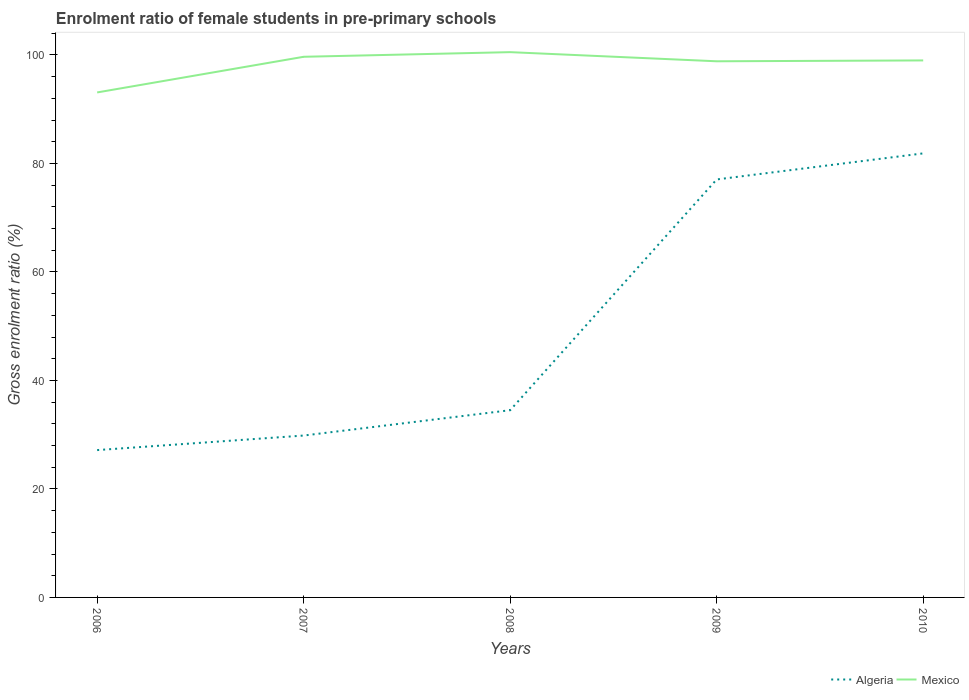How many different coloured lines are there?
Make the answer very short. 2. Does the line corresponding to Mexico intersect with the line corresponding to Algeria?
Provide a short and direct response. No. Across all years, what is the maximum enrolment ratio of female students in pre-primary schools in Algeria?
Your answer should be very brief. 27.16. In which year was the enrolment ratio of female students in pre-primary schools in Algeria maximum?
Ensure brevity in your answer.  2006. What is the total enrolment ratio of female students in pre-primary schools in Algeria in the graph?
Keep it short and to the point. -7.36. What is the difference between the highest and the second highest enrolment ratio of female students in pre-primary schools in Mexico?
Keep it short and to the point. 7.43. Is the enrolment ratio of female students in pre-primary schools in Algeria strictly greater than the enrolment ratio of female students in pre-primary schools in Mexico over the years?
Your answer should be compact. Yes. How many lines are there?
Provide a succinct answer. 2. How many years are there in the graph?
Offer a very short reply. 5. What is the difference between two consecutive major ticks on the Y-axis?
Offer a very short reply. 20. Does the graph contain any zero values?
Make the answer very short. No. Where does the legend appear in the graph?
Provide a succinct answer. Bottom right. How many legend labels are there?
Ensure brevity in your answer.  2. How are the legend labels stacked?
Your answer should be very brief. Horizontal. What is the title of the graph?
Give a very brief answer. Enrolment ratio of female students in pre-primary schools. What is the label or title of the X-axis?
Ensure brevity in your answer.  Years. What is the label or title of the Y-axis?
Your answer should be very brief. Gross enrolment ratio (%). What is the Gross enrolment ratio (%) of Algeria in 2006?
Offer a very short reply. 27.16. What is the Gross enrolment ratio (%) in Mexico in 2006?
Ensure brevity in your answer.  93.1. What is the Gross enrolment ratio (%) of Algeria in 2007?
Make the answer very short. 29.84. What is the Gross enrolment ratio (%) in Mexico in 2007?
Ensure brevity in your answer.  99.67. What is the Gross enrolment ratio (%) of Algeria in 2008?
Make the answer very short. 34.52. What is the Gross enrolment ratio (%) of Mexico in 2008?
Your answer should be very brief. 100.52. What is the Gross enrolment ratio (%) in Algeria in 2009?
Ensure brevity in your answer.  77.06. What is the Gross enrolment ratio (%) of Mexico in 2009?
Provide a short and direct response. 98.84. What is the Gross enrolment ratio (%) in Algeria in 2010?
Keep it short and to the point. 81.86. What is the Gross enrolment ratio (%) of Mexico in 2010?
Your answer should be very brief. 99. Across all years, what is the maximum Gross enrolment ratio (%) of Algeria?
Give a very brief answer. 81.86. Across all years, what is the maximum Gross enrolment ratio (%) in Mexico?
Keep it short and to the point. 100.52. Across all years, what is the minimum Gross enrolment ratio (%) in Algeria?
Your response must be concise. 27.16. Across all years, what is the minimum Gross enrolment ratio (%) of Mexico?
Give a very brief answer. 93.1. What is the total Gross enrolment ratio (%) of Algeria in the graph?
Ensure brevity in your answer.  250.44. What is the total Gross enrolment ratio (%) of Mexico in the graph?
Offer a terse response. 491.13. What is the difference between the Gross enrolment ratio (%) in Algeria in 2006 and that in 2007?
Offer a very short reply. -2.68. What is the difference between the Gross enrolment ratio (%) of Mexico in 2006 and that in 2007?
Give a very brief answer. -6.57. What is the difference between the Gross enrolment ratio (%) in Algeria in 2006 and that in 2008?
Give a very brief answer. -7.36. What is the difference between the Gross enrolment ratio (%) in Mexico in 2006 and that in 2008?
Provide a succinct answer. -7.43. What is the difference between the Gross enrolment ratio (%) of Algeria in 2006 and that in 2009?
Give a very brief answer. -49.9. What is the difference between the Gross enrolment ratio (%) of Mexico in 2006 and that in 2009?
Offer a very short reply. -5.74. What is the difference between the Gross enrolment ratio (%) of Algeria in 2006 and that in 2010?
Your answer should be very brief. -54.7. What is the difference between the Gross enrolment ratio (%) of Mexico in 2006 and that in 2010?
Offer a terse response. -5.9. What is the difference between the Gross enrolment ratio (%) of Algeria in 2007 and that in 2008?
Ensure brevity in your answer.  -4.67. What is the difference between the Gross enrolment ratio (%) in Mexico in 2007 and that in 2008?
Give a very brief answer. -0.86. What is the difference between the Gross enrolment ratio (%) of Algeria in 2007 and that in 2009?
Keep it short and to the point. -47.21. What is the difference between the Gross enrolment ratio (%) of Mexico in 2007 and that in 2009?
Provide a short and direct response. 0.83. What is the difference between the Gross enrolment ratio (%) in Algeria in 2007 and that in 2010?
Offer a terse response. -52.02. What is the difference between the Gross enrolment ratio (%) in Mexico in 2007 and that in 2010?
Make the answer very short. 0.67. What is the difference between the Gross enrolment ratio (%) in Algeria in 2008 and that in 2009?
Your response must be concise. -42.54. What is the difference between the Gross enrolment ratio (%) of Mexico in 2008 and that in 2009?
Provide a short and direct response. 1.68. What is the difference between the Gross enrolment ratio (%) in Algeria in 2008 and that in 2010?
Offer a very short reply. -47.34. What is the difference between the Gross enrolment ratio (%) of Mexico in 2008 and that in 2010?
Your response must be concise. 1.52. What is the difference between the Gross enrolment ratio (%) in Algeria in 2009 and that in 2010?
Keep it short and to the point. -4.8. What is the difference between the Gross enrolment ratio (%) of Mexico in 2009 and that in 2010?
Give a very brief answer. -0.16. What is the difference between the Gross enrolment ratio (%) of Algeria in 2006 and the Gross enrolment ratio (%) of Mexico in 2007?
Your response must be concise. -72.51. What is the difference between the Gross enrolment ratio (%) in Algeria in 2006 and the Gross enrolment ratio (%) in Mexico in 2008?
Offer a terse response. -73.36. What is the difference between the Gross enrolment ratio (%) of Algeria in 2006 and the Gross enrolment ratio (%) of Mexico in 2009?
Keep it short and to the point. -71.68. What is the difference between the Gross enrolment ratio (%) of Algeria in 2006 and the Gross enrolment ratio (%) of Mexico in 2010?
Ensure brevity in your answer.  -71.84. What is the difference between the Gross enrolment ratio (%) of Algeria in 2007 and the Gross enrolment ratio (%) of Mexico in 2008?
Your response must be concise. -70.68. What is the difference between the Gross enrolment ratio (%) of Algeria in 2007 and the Gross enrolment ratio (%) of Mexico in 2009?
Give a very brief answer. -69. What is the difference between the Gross enrolment ratio (%) of Algeria in 2007 and the Gross enrolment ratio (%) of Mexico in 2010?
Offer a terse response. -69.15. What is the difference between the Gross enrolment ratio (%) in Algeria in 2008 and the Gross enrolment ratio (%) in Mexico in 2009?
Give a very brief answer. -64.32. What is the difference between the Gross enrolment ratio (%) of Algeria in 2008 and the Gross enrolment ratio (%) of Mexico in 2010?
Offer a very short reply. -64.48. What is the difference between the Gross enrolment ratio (%) in Algeria in 2009 and the Gross enrolment ratio (%) in Mexico in 2010?
Offer a very short reply. -21.94. What is the average Gross enrolment ratio (%) in Algeria per year?
Give a very brief answer. 50.09. What is the average Gross enrolment ratio (%) in Mexico per year?
Give a very brief answer. 98.23. In the year 2006, what is the difference between the Gross enrolment ratio (%) in Algeria and Gross enrolment ratio (%) in Mexico?
Give a very brief answer. -65.94. In the year 2007, what is the difference between the Gross enrolment ratio (%) of Algeria and Gross enrolment ratio (%) of Mexico?
Give a very brief answer. -69.82. In the year 2008, what is the difference between the Gross enrolment ratio (%) of Algeria and Gross enrolment ratio (%) of Mexico?
Provide a succinct answer. -66.01. In the year 2009, what is the difference between the Gross enrolment ratio (%) of Algeria and Gross enrolment ratio (%) of Mexico?
Make the answer very short. -21.78. In the year 2010, what is the difference between the Gross enrolment ratio (%) of Algeria and Gross enrolment ratio (%) of Mexico?
Your answer should be compact. -17.14. What is the ratio of the Gross enrolment ratio (%) of Algeria in 2006 to that in 2007?
Your answer should be compact. 0.91. What is the ratio of the Gross enrolment ratio (%) of Mexico in 2006 to that in 2007?
Your answer should be compact. 0.93. What is the ratio of the Gross enrolment ratio (%) of Algeria in 2006 to that in 2008?
Provide a succinct answer. 0.79. What is the ratio of the Gross enrolment ratio (%) of Mexico in 2006 to that in 2008?
Offer a terse response. 0.93. What is the ratio of the Gross enrolment ratio (%) of Algeria in 2006 to that in 2009?
Your answer should be very brief. 0.35. What is the ratio of the Gross enrolment ratio (%) of Mexico in 2006 to that in 2009?
Your answer should be very brief. 0.94. What is the ratio of the Gross enrolment ratio (%) in Algeria in 2006 to that in 2010?
Provide a succinct answer. 0.33. What is the ratio of the Gross enrolment ratio (%) of Mexico in 2006 to that in 2010?
Provide a succinct answer. 0.94. What is the ratio of the Gross enrolment ratio (%) in Algeria in 2007 to that in 2008?
Ensure brevity in your answer.  0.86. What is the ratio of the Gross enrolment ratio (%) of Algeria in 2007 to that in 2009?
Provide a succinct answer. 0.39. What is the ratio of the Gross enrolment ratio (%) of Mexico in 2007 to that in 2009?
Offer a very short reply. 1.01. What is the ratio of the Gross enrolment ratio (%) of Algeria in 2007 to that in 2010?
Your response must be concise. 0.36. What is the ratio of the Gross enrolment ratio (%) in Mexico in 2007 to that in 2010?
Offer a very short reply. 1.01. What is the ratio of the Gross enrolment ratio (%) in Algeria in 2008 to that in 2009?
Your answer should be very brief. 0.45. What is the ratio of the Gross enrolment ratio (%) of Algeria in 2008 to that in 2010?
Keep it short and to the point. 0.42. What is the ratio of the Gross enrolment ratio (%) in Mexico in 2008 to that in 2010?
Your answer should be compact. 1.02. What is the ratio of the Gross enrolment ratio (%) in Algeria in 2009 to that in 2010?
Ensure brevity in your answer.  0.94. What is the difference between the highest and the second highest Gross enrolment ratio (%) in Algeria?
Provide a succinct answer. 4.8. What is the difference between the highest and the second highest Gross enrolment ratio (%) of Mexico?
Give a very brief answer. 0.86. What is the difference between the highest and the lowest Gross enrolment ratio (%) of Algeria?
Make the answer very short. 54.7. What is the difference between the highest and the lowest Gross enrolment ratio (%) of Mexico?
Offer a terse response. 7.43. 